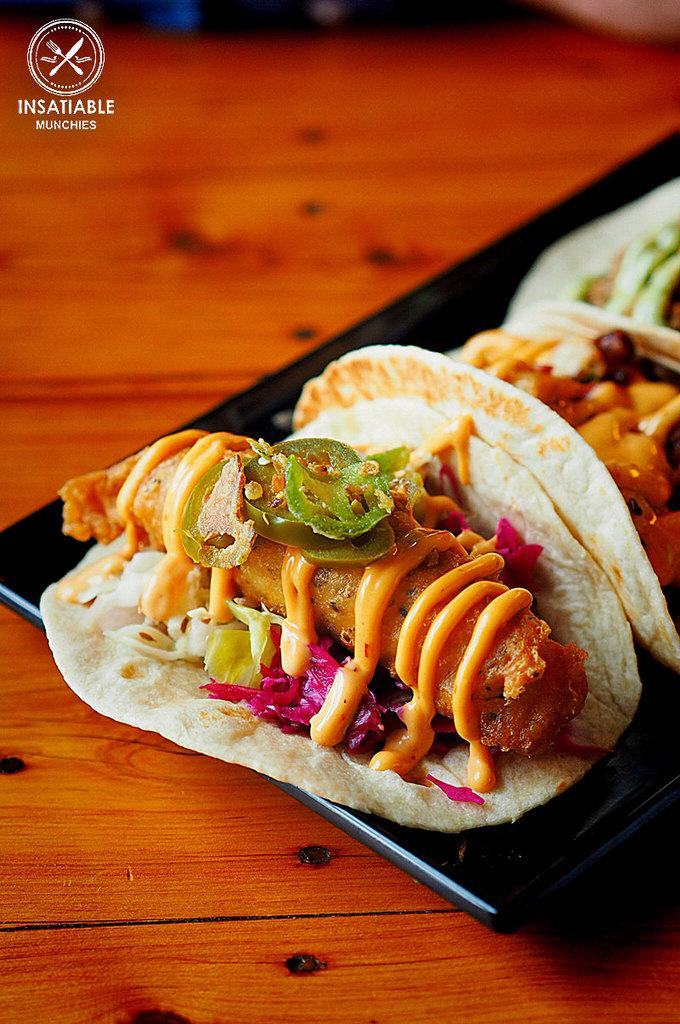What is on the plate that is visible in the image? There are food items on a plate in the image. Where is the plate located in the image? The plate is on a table in the image. Can you describe any additional features of the image? There is a watermark on the image. What type of badge is visible on the plate in the image? There is no badge present on the plate in the image. Can you describe the texture of the shame in the image? There is no shame present in the image, and therefore no texture to describe. 